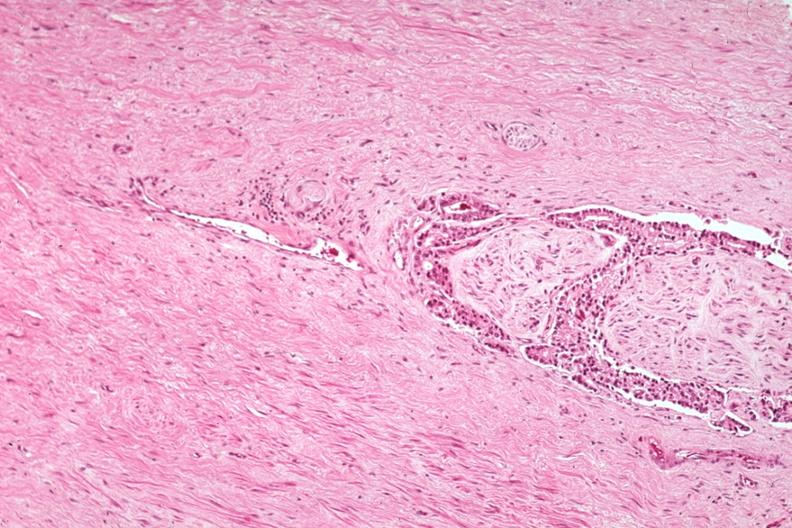s prostate present?
Answer the question using a single word or phrase. Yes 